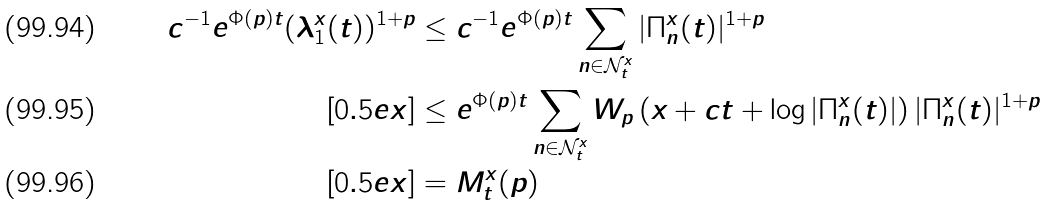<formula> <loc_0><loc_0><loc_500><loc_500>c ^ { - 1 } e ^ { \Phi ( p ) t } ( \lambda ^ { x } _ { 1 } ( t ) ) ^ { 1 + p } & \leq c ^ { - 1 } e ^ { \Phi ( p ) t } \sum _ { n \in \mathcal { N } ^ { x } _ { t } } | \Pi ^ { x } _ { n } ( t ) | ^ { 1 + p } \\ [ 0 . 5 e x ] & \leq e ^ { \Phi ( p ) t } \sum _ { n \in \mathcal { N } ^ { x } _ { t } } W _ { p } \left ( x + c t + \log | \Pi ^ { x } _ { n } ( t ) | \right ) | \Pi ^ { x } _ { n } ( t ) | ^ { 1 + p } \\ [ 0 . 5 e x ] & = M ^ { x } _ { t } ( p )</formula> 